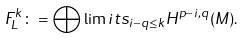Convert formula to latex. <formula><loc_0><loc_0><loc_500><loc_500>F ^ { k } _ { L } \colon = \bigoplus \lim i t s _ { i - q \leq k } H ^ { p - i , q } ( M ) .</formula> 